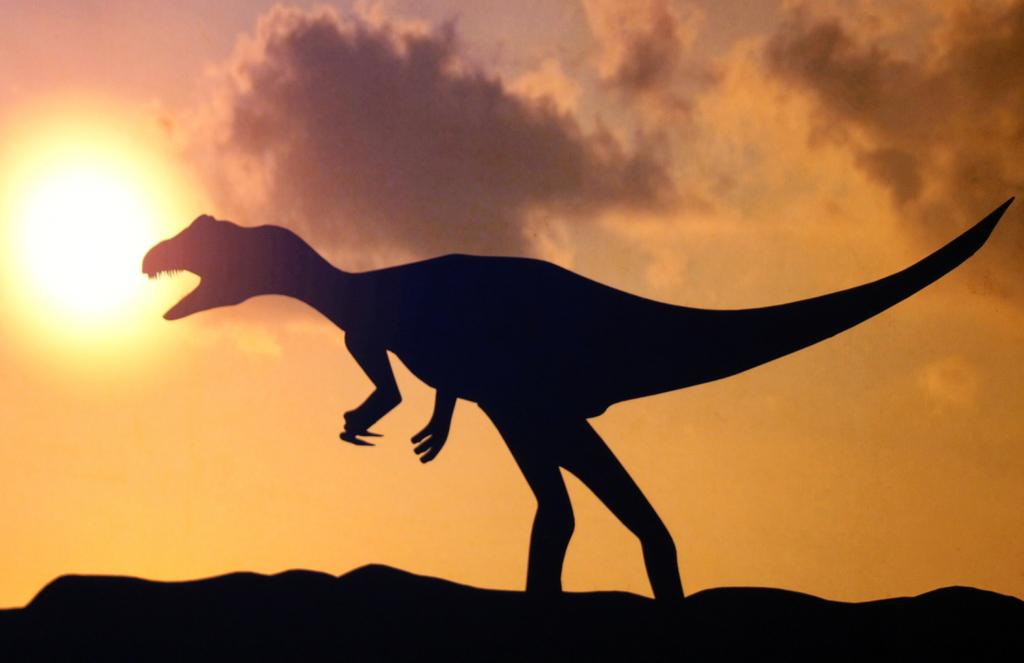What is the main subject of the picture? There is a dinosaur in the picture. How is the dinosaur positioned in the image? The dinosaur is standing on the ground. What is the condition of the sun in the image? The sun is bright in the image. What is the governor's opinion on the argument between the dinosaur and the sun in the image? There is no governor or argument present in the image; it features a dinosaur standing on the ground with a bright sun in the background. 